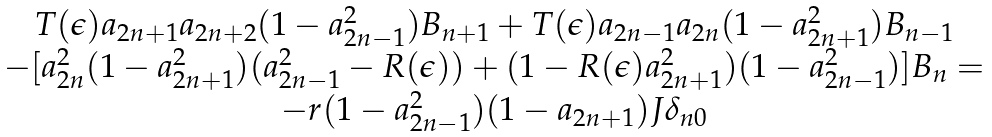Convert formula to latex. <formula><loc_0><loc_0><loc_500><loc_500>\begin{array} { c c } T ( \epsilon ) a _ { 2 n + 1 } a _ { 2 n + 2 } ( 1 - a _ { 2 n - 1 } ^ { 2 } ) B _ { n + 1 } + T ( \epsilon ) a _ { 2 n - 1 } a _ { 2 n } ( 1 - a _ { 2 n + 1 } ^ { 2 } ) B _ { n - 1 } \\ - [ a _ { 2 n } ^ { 2 } ( 1 - a _ { 2 n + 1 } ^ { 2 } ) ( a _ { 2 n - 1 } ^ { 2 } - R ( \epsilon ) ) + ( 1 - R ( \epsilon ) a _ { 2 n + 1 } ^ { 2 } ) ( 1 - a _ { 2 n - 1 } ^ { 2 } ) ] B _ { n } = \\ - r ( 1 - a _ { 2 n - 1 } ^ { 2 } ) ( 1 - a _ { 2 n + 1 } ) J \delta _ { n 0 } \end{array}</formula> 